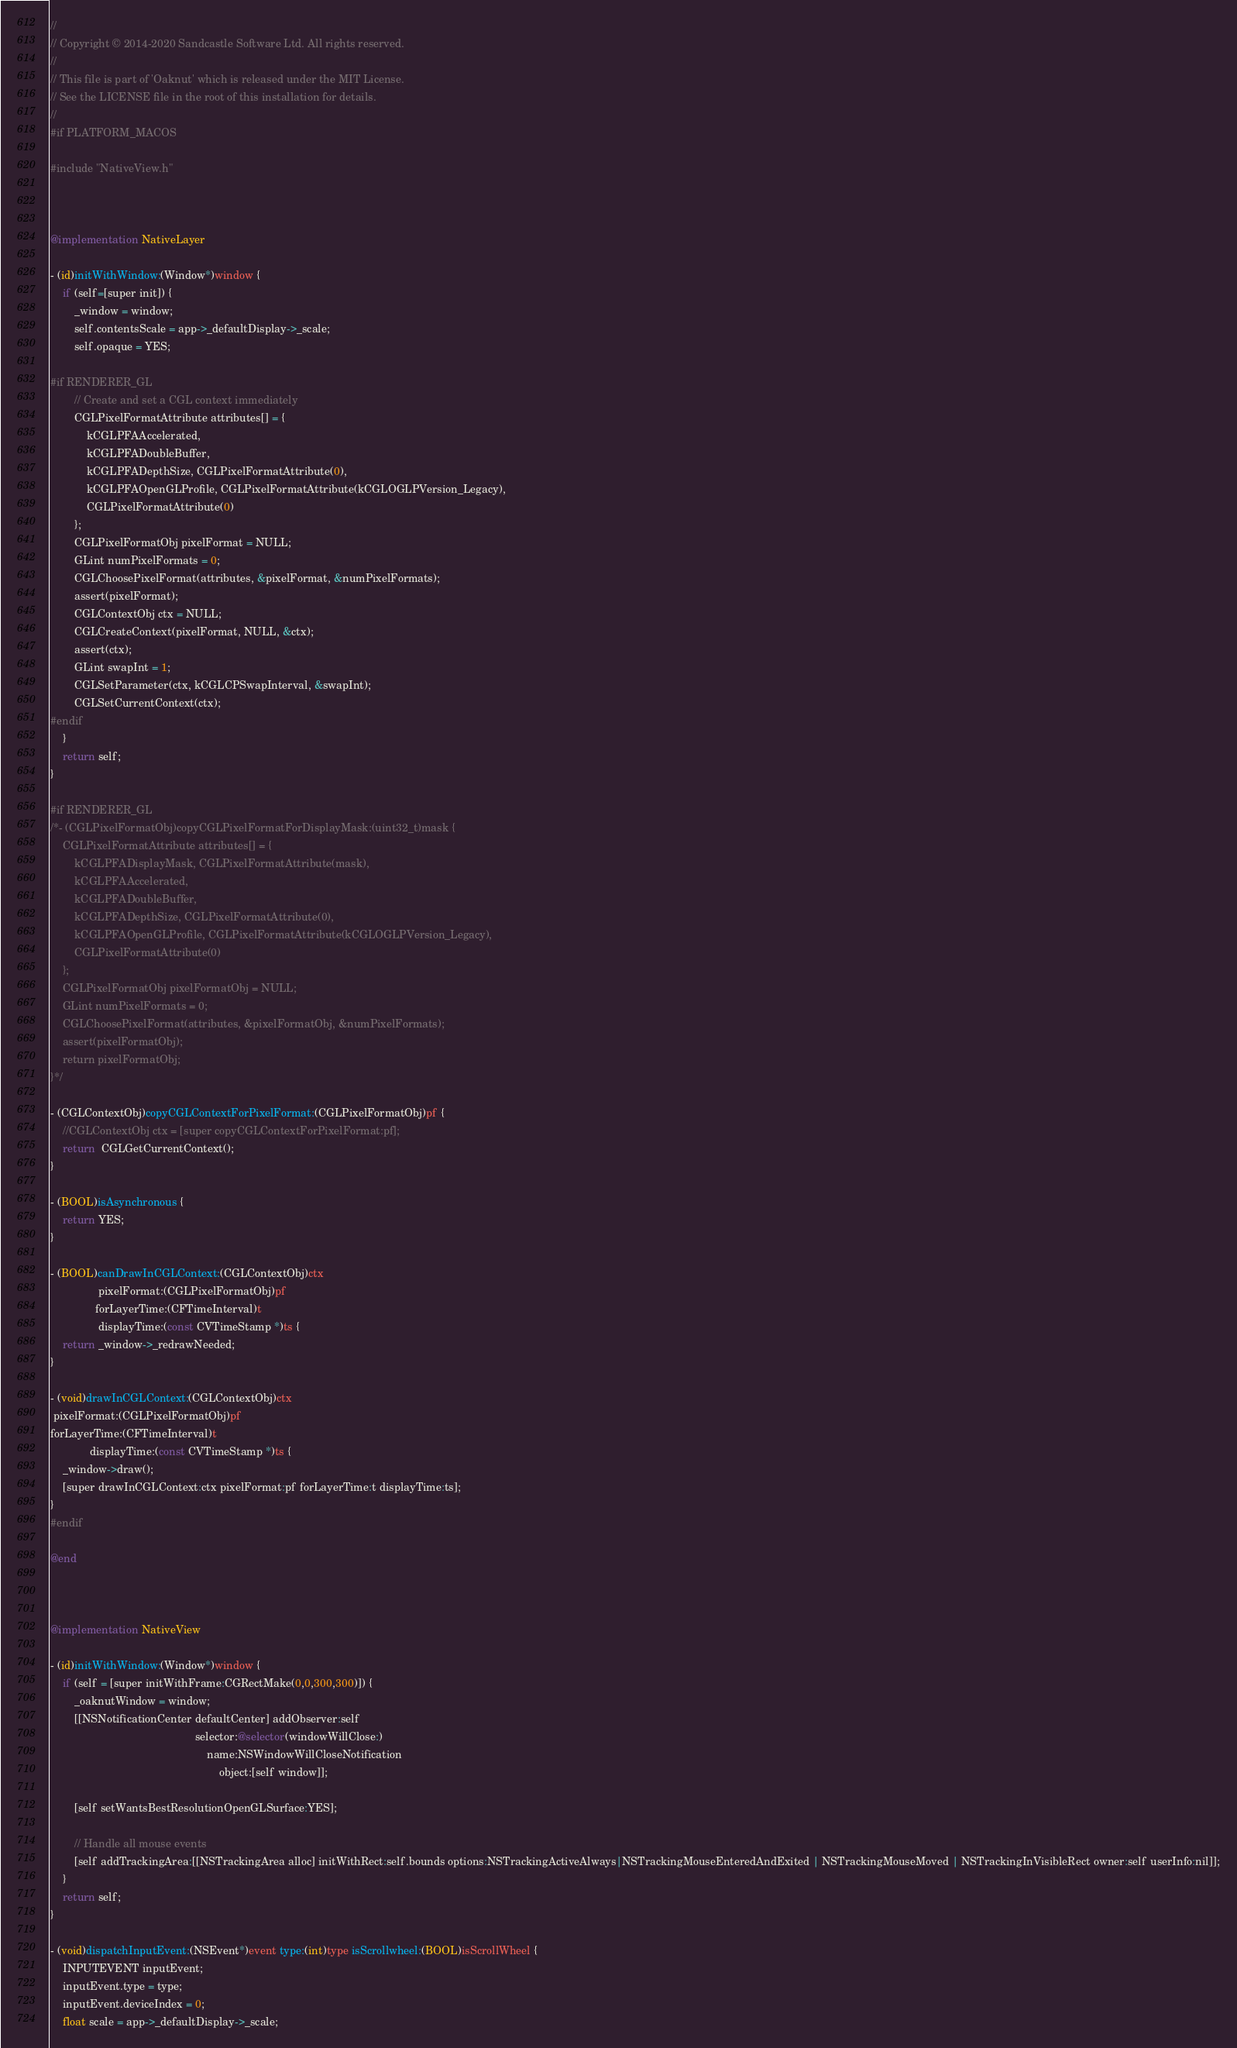<code> <loc_0><loc_0><loc_500><loc_500><_ObjectiveC_>//
// Copyright © 2014-2020 Sandcastle Software Ltd. All rights reserved.
//
// This file is part of 'Oaknut' which is released under the MIT License.
// See the LICENSE file in the root of this installation for details.
//
#if PLATFORM_MACOS

#include "NativeView.h"



@implementation NativeLayer

- (id)initWithWindow:(Window*)window {
    if (self=[super init]) {
        _window = window;
        self.contentsScale = app->_defaultDisplay->_scale;
        self.opaque = YES;
        
#if RENDERER_GL
        // Create and set a CGL context immediately
        CGLPixelFormatAttribute attributes[] = {
            kCGLPFAAccelerated,
            kCGLPFADoubleBuffer,
            kCGLPFADepthSize, CGLPixelFormatAttribute(0),
            kCGLPFAOpenGLProfile, CGLPixelFormatAttribute(kCGLOGLPVersion_Legacy),
            CGLPixelFormatAttribute(0)
        };
        CGLPixelFormatObj pixelFormat = NULL;
        GLint numPixelFormats = 0;
        CGLChoosePixelFormat(attributes, &pixelFormat, &numPixelFormats);
        assert(pixelFormat);
        CGLContextObj ctx = NULL;
        CGLCreateContext(pixelFormat, NULL, &ctx);
        assert(ctx);
        GLint swapInt = 1;
        CGLSetParameter(ctx, kCGLCPSwapInterval, &swapInt);
        CGLSetCurrentContext(ctx);
#endif
    }
    return self;
}

#if RENDERER_GL
/*- (CGLPixelFormatObj)copyCGLPixelFormatForDisplayMask:(uint32_t)mask {
    CGLPixelFormatAttribute attributes[] = {
        kCGLPFADisplayMask, CGLPixelFormatAttribute(mask),
        kCGLPFAAccelerated,
        kCGLPFADoubleBuffer,
        kCGLPFADepthSize, CGLPixelFormatAttribute(0),
        kCGLPFAOpenGLProfile, CGLPixelFormatAttribute(kCGLOGLPVersion_Legacy),
        CGLPixelFormatAttribute(0)
    };
    CGLPixelFormatObj pixelFormatObj = NULL;
    GLint numPixelFormats = 0;
    CGLChoosePixelFormat(attributes, &pixelFormatObj, &numPixelFormats);
    assert(pixelFormatObj);
    return pixelFormatObj;
}*/

- (CGLContextObj)copyCGLContextForPixelFormat:(CGLPixelFormatObj)pf {
    //CGLContextObj ctx = [super copyCGLContextForPixelFormat:pf];
    return  CGLGetCurrentContext();
}

- (BOOL)isAsynchronous {
    return YES;
}

- (BOOL)canDrawInCGLContext:(CGLContextObj)ctx
                pixelFormat:(CGLPixelFormatObj)pf
               forLayerTime:(CFTimeInterval)t
                displayTime:(const CVTimeStamp *)ts {
    return _window->_redrawNeeded;
}

- (void)drawInCGLContext:(CGLContextObj)ctx
 pixelFormat:(CGLPixelFormatObj)pf
forLayerTime:(CFTimeInterval)t
             displayTime:(const CVTimeStamp *)ts {
    _window->draw();
    [super drawInCGLContext:ctx pixelFormat:pf forLayerTime:t displayTime:ts];
}
#endif

@end



@implementation NativeView

- (id)initWithWindow:(Window*)window {
    if (self = [super initWithFrame:CGRectMake(0,0,300,300)]) {
        _oaknutWindow = window;
        [[NSNotificationCenter defaultCenter] addObserver:self
                                                selector:@selector(windowWillClose:)
                                                    name:NSWindowWillCloseNotification
                                                        object:[self window]];
        
        [self setWantsBestResolutionOpenGLSurface:YES];
        
        // Handle all mouse events
        [self addTrackingArea:[[NSTrackingArea alloc] initWithRect:self.bounds options:NSTrackingActiveAlways|NSTrackingMouseEnteredAndExited | NSTrackingMouseMoved | NSTrackingInVisibleRect owner:self userInfo:nil]];
    }
    return self;
}

- (void)dispatchInputEvent:(NSEvent*)event type:(int)type isScrollwheel:(BOOL)isScrollWheel {
    INPUTEVENT inputEvent;
    inputEvent.type = type;
    inputEvent.deviceIndex = 0;
    float scale = app->_defaultDisplay->_scale;</code> 